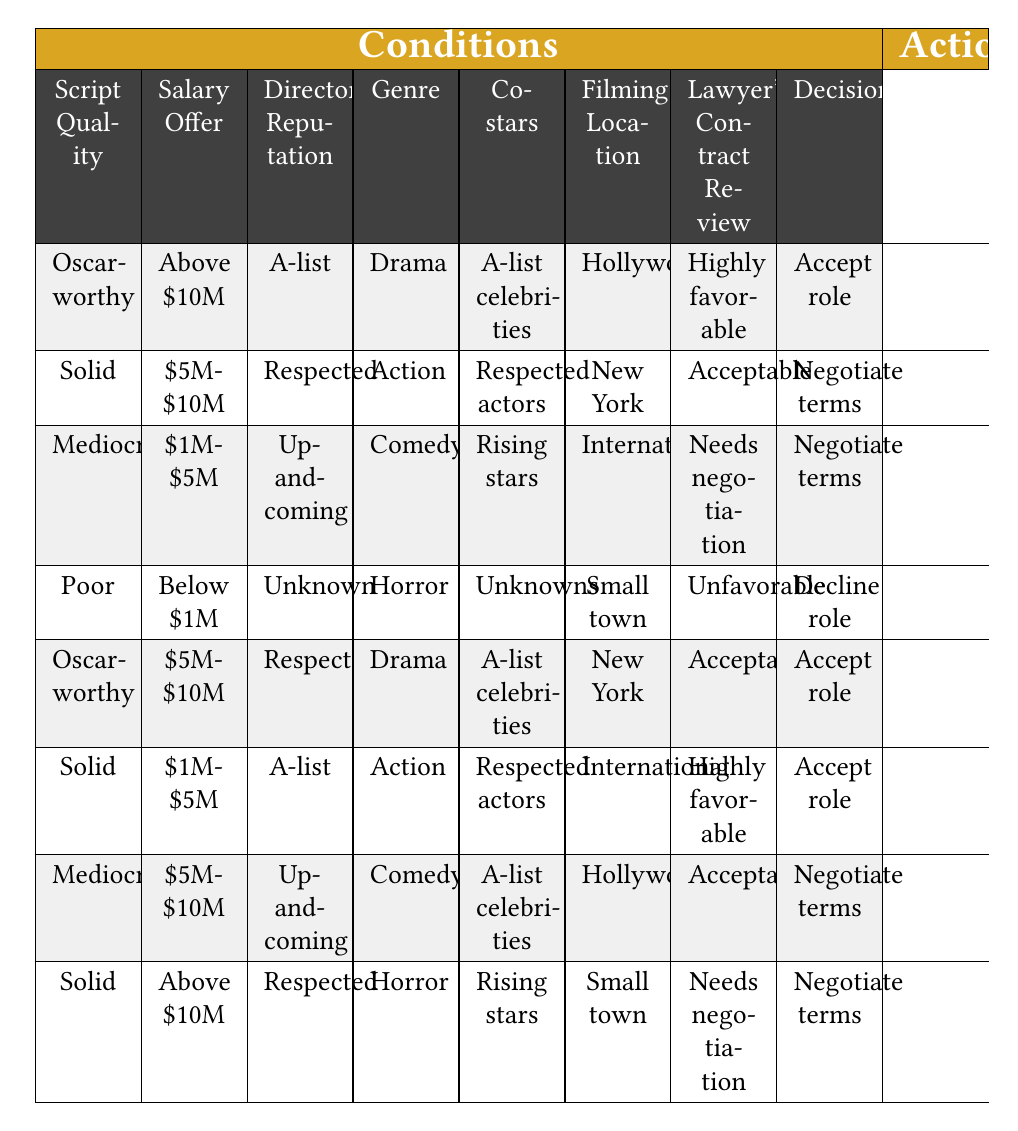What decision is made when the script quality is Poor and the salary offer is Below $1M? In the table, when the script quality is Poor and the salary is Below $1M, the conditions in that row indicate that the decision is to "Decline role."
Answer: Decline role What is the condition that leads to accepting a role with A-list celebrities and 5M to 10M dollar salary? There are multiple rows where this condition applies, including one that specifies "Oscar-worthy" script quality and "Acceptable" lawyer's contract review, which results in accepting the role.
Answer: Accept role Is the director's reputation always A-list when the decision is to accept a role? No, looking at the table, there are instances where the director's reputation is either Respected or A-list when accepting a role, meaning it is not always A-list.
Answer: No What is the most common decision when the script quality is Solid? There are two instances with the script quality as Solid; one results in "Negotiate terms" and the other in "Accept role." Thus, analyzing these outcomes will show that Solid leads to different decisions without a clear common answer.
Answer: No clear common decision In how many cases does an Oscar-worthy script quality lead to accepting a role? There are two rows with Oscar-worthy script quality. In both instances, the decision is to "Accept role." Hence, there are two such cases where the outcome is the same.
Answer: 2 